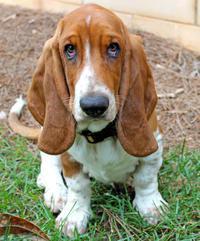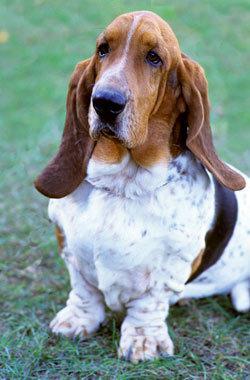The first image is the image on the left, the second image is the image on the right. Examine the images to the left and right. Is the description "One of the dog's front paws are not on the grass." accurate? Answer yes or no. No. The first image is the image on the left, the second image is the image on the right. For the images shown, is this caption "All dogs pictured have visible collars." true? Answer yes or no. No. The first image is the image on the left, the second image is the image on the right. Assess this claim about the two images: "One of the images contains two or more basset hounds.". Correct or not? Answer yes or no. No. 